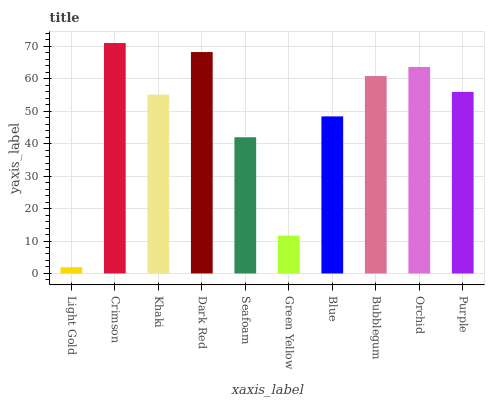Is Light Gold the minimum?
Answer yes or no. Yes. Is Crimson the maximum?
Answer yes or no. Yes. Is Khaki the minimum?
Answer yes or no. No. Is Khaki the maximum?
Answer yes or no. No. Is Crimson greater than Khaki?
Answer yes or no. Yes. Is Khaki less than Crimson?
Answer yes or no. Yes. Is Khaki greater than Crimson?
Answer yes or no. No. Is Crimson less than Khaki?
Answer yes or no. No. Is Purple the high median?
Answer yes or no. Yes. Is Khaki the low median?
Answer yes or no. Yes. Is Orchid the high median?
Answer yes or no. No. Is Seafoam the low median?
Answer yes or no. No. 